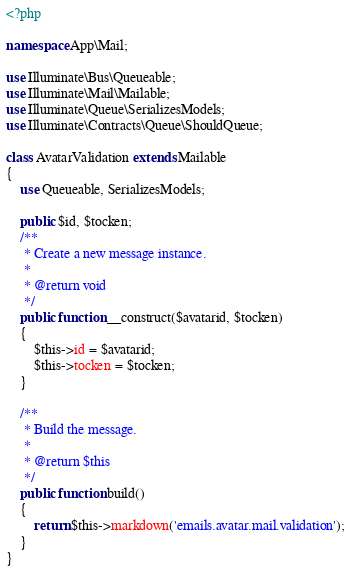<code> <loc_0><loc_0><loc_500><loc_500><_PHP_><?php

namespace App\Mail;

use Illuminate\Bus\Queueable;
use Illuminate\Mail\Mailable;
use Illuminate\Queue\SerializesModels;
use Illuminate\Contracts\Queue\ShouldQueue;

class AvatarValidation extends Mailable
{
    use Queueable, SerializesModels;

    public $id, $tocken;
    /**
     * Create a new message instance.
     *
     * @return void
     */
    public function __construct($avatarid, $tocken)
    {
        $this->id = $avatarid;
        $this->tocken = $tocken;
    }

    /**
     * Build the message.
     *
     * @return $this
     */
    public function build()
    {
        return $this->markdown('emails.avatar.mail.validation');
    }
}
</code> 